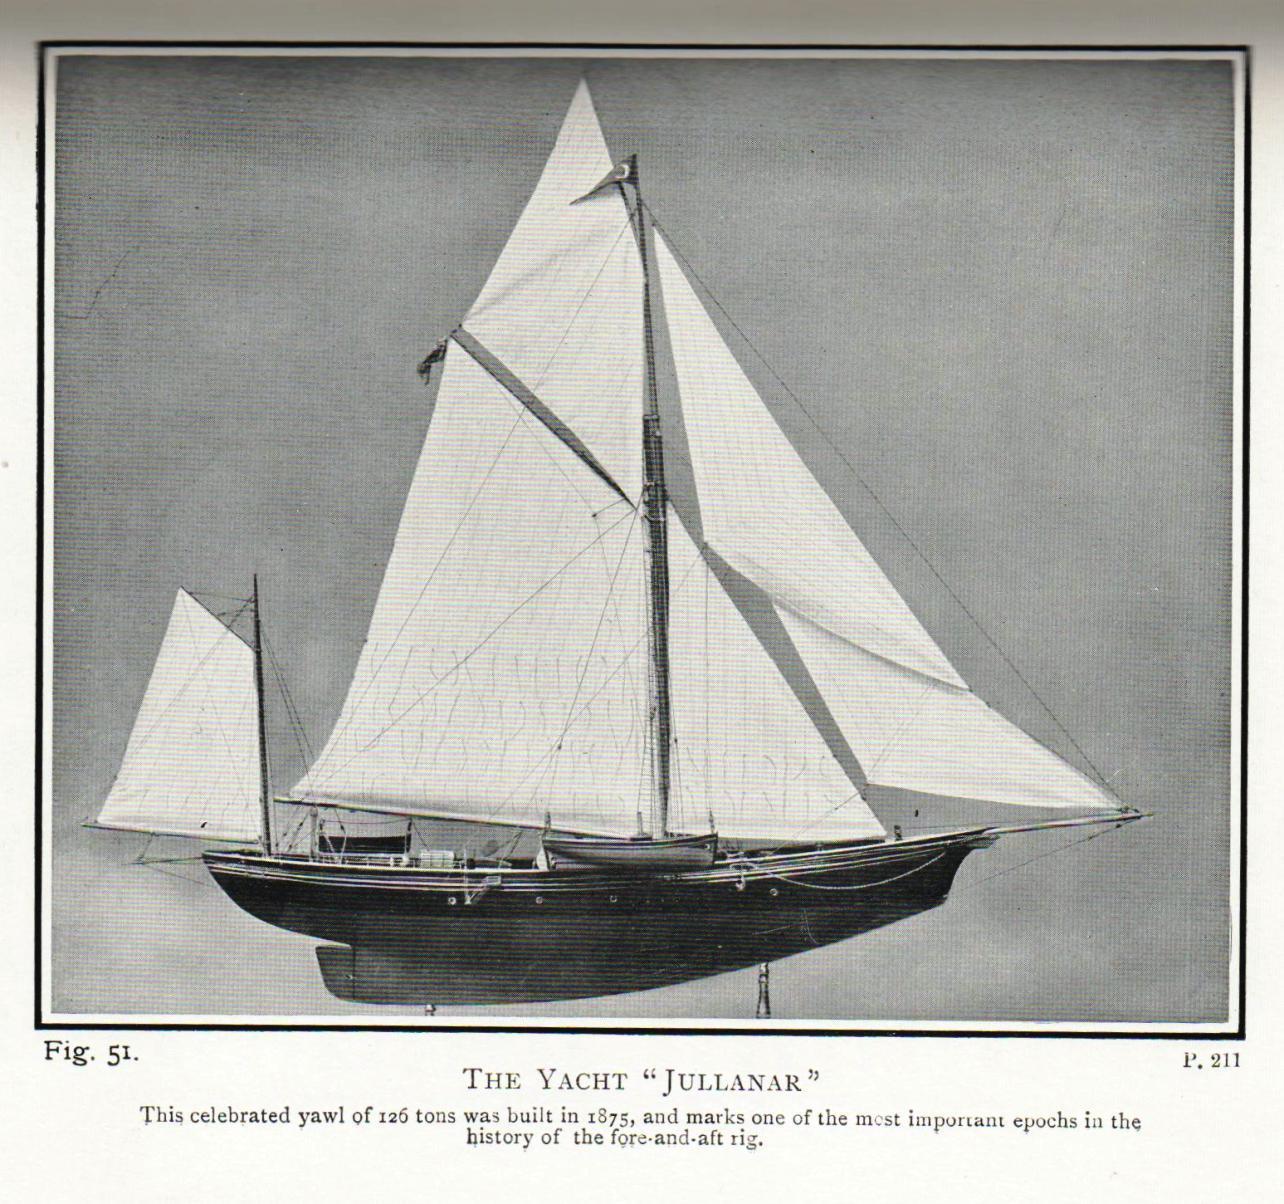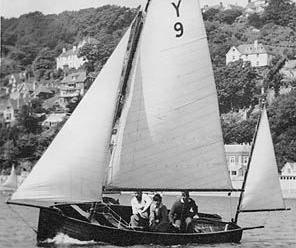The first image is the image on the left, the second image is the image on the right. Assess this claim about the two images: "One of the images shows a sail with a number on it.". Correct or not? Answer yes or no. Yes. The first image is the image on the left, the second image is the image on the right. For the images shown, is this caption "A hillside at least half the height of the whole image is in the background of a scene with a sailing boat." true? Answer yes or no. Yes. 